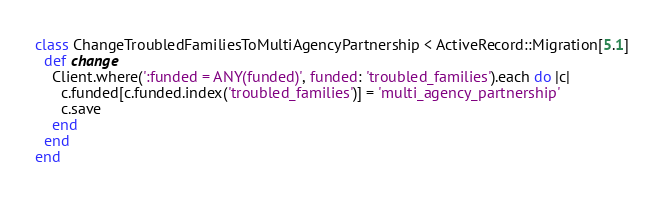Convert code to text. <code><loc_0><loc_0><loc_500><loc_500><_Ruby_>class ChangeTroubledFamiliesToMultiAgencyPartnership < ActiveRecord::Migration[5.1]
  def change
    Client.where(':funded = ANY(funded)', funded: 'troubled_families').each do |c|
      c.funded[c.funded.index('troubled_families')] = 'multi_agency_partnership'
      c.save
    end
  end
end
</code> 